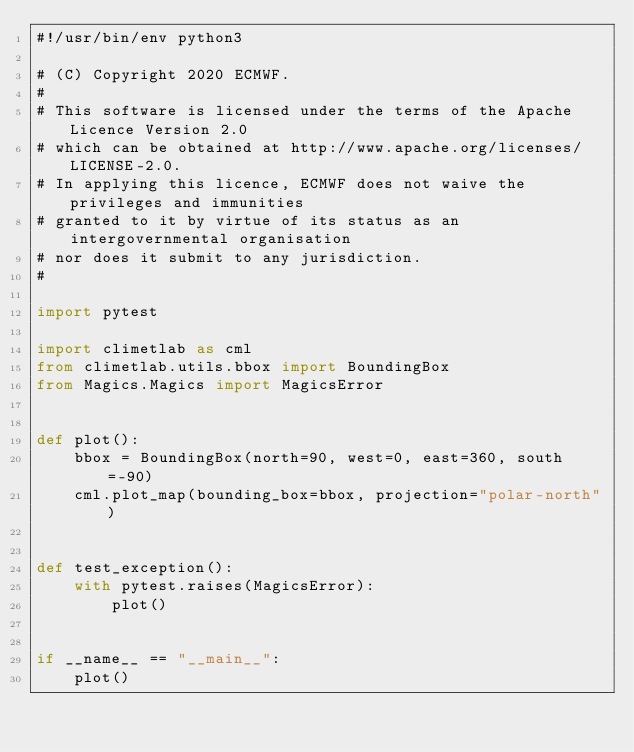Convert code to text. <code><loc_0><loc_0><loc_500><loc_500><_Python_>#!/usr/bin/env python3

# (C) Copyright 2020 ECMWF.
#
# This software is licensed under the terms of the Apache Licence Version 2.0
# which can be obtained at http://www.apache.org/licenses/LICENSE-2.0.
# In applying this licence, ECMWF does not waive the privileges and immunities
# granted to it by virtue of its status as an intergovernmental organisation
# nor does it submit to any jurisdiction.
#

import pytest

import climetlab as cml
from climetlab.utils.bbox import BoundingBox
from Magics.Magics import MagicsError


def plot():
    bbox = BoundingBox(north=90, west=0, east=360, south=-90)
    cml.plot_map(bounding_box=bbox, projection="polar-north")


def test_exception():
    with pytest.raises(MagicsError):
        plot()


if __name__ == "__main__":
    plot()
</code> 